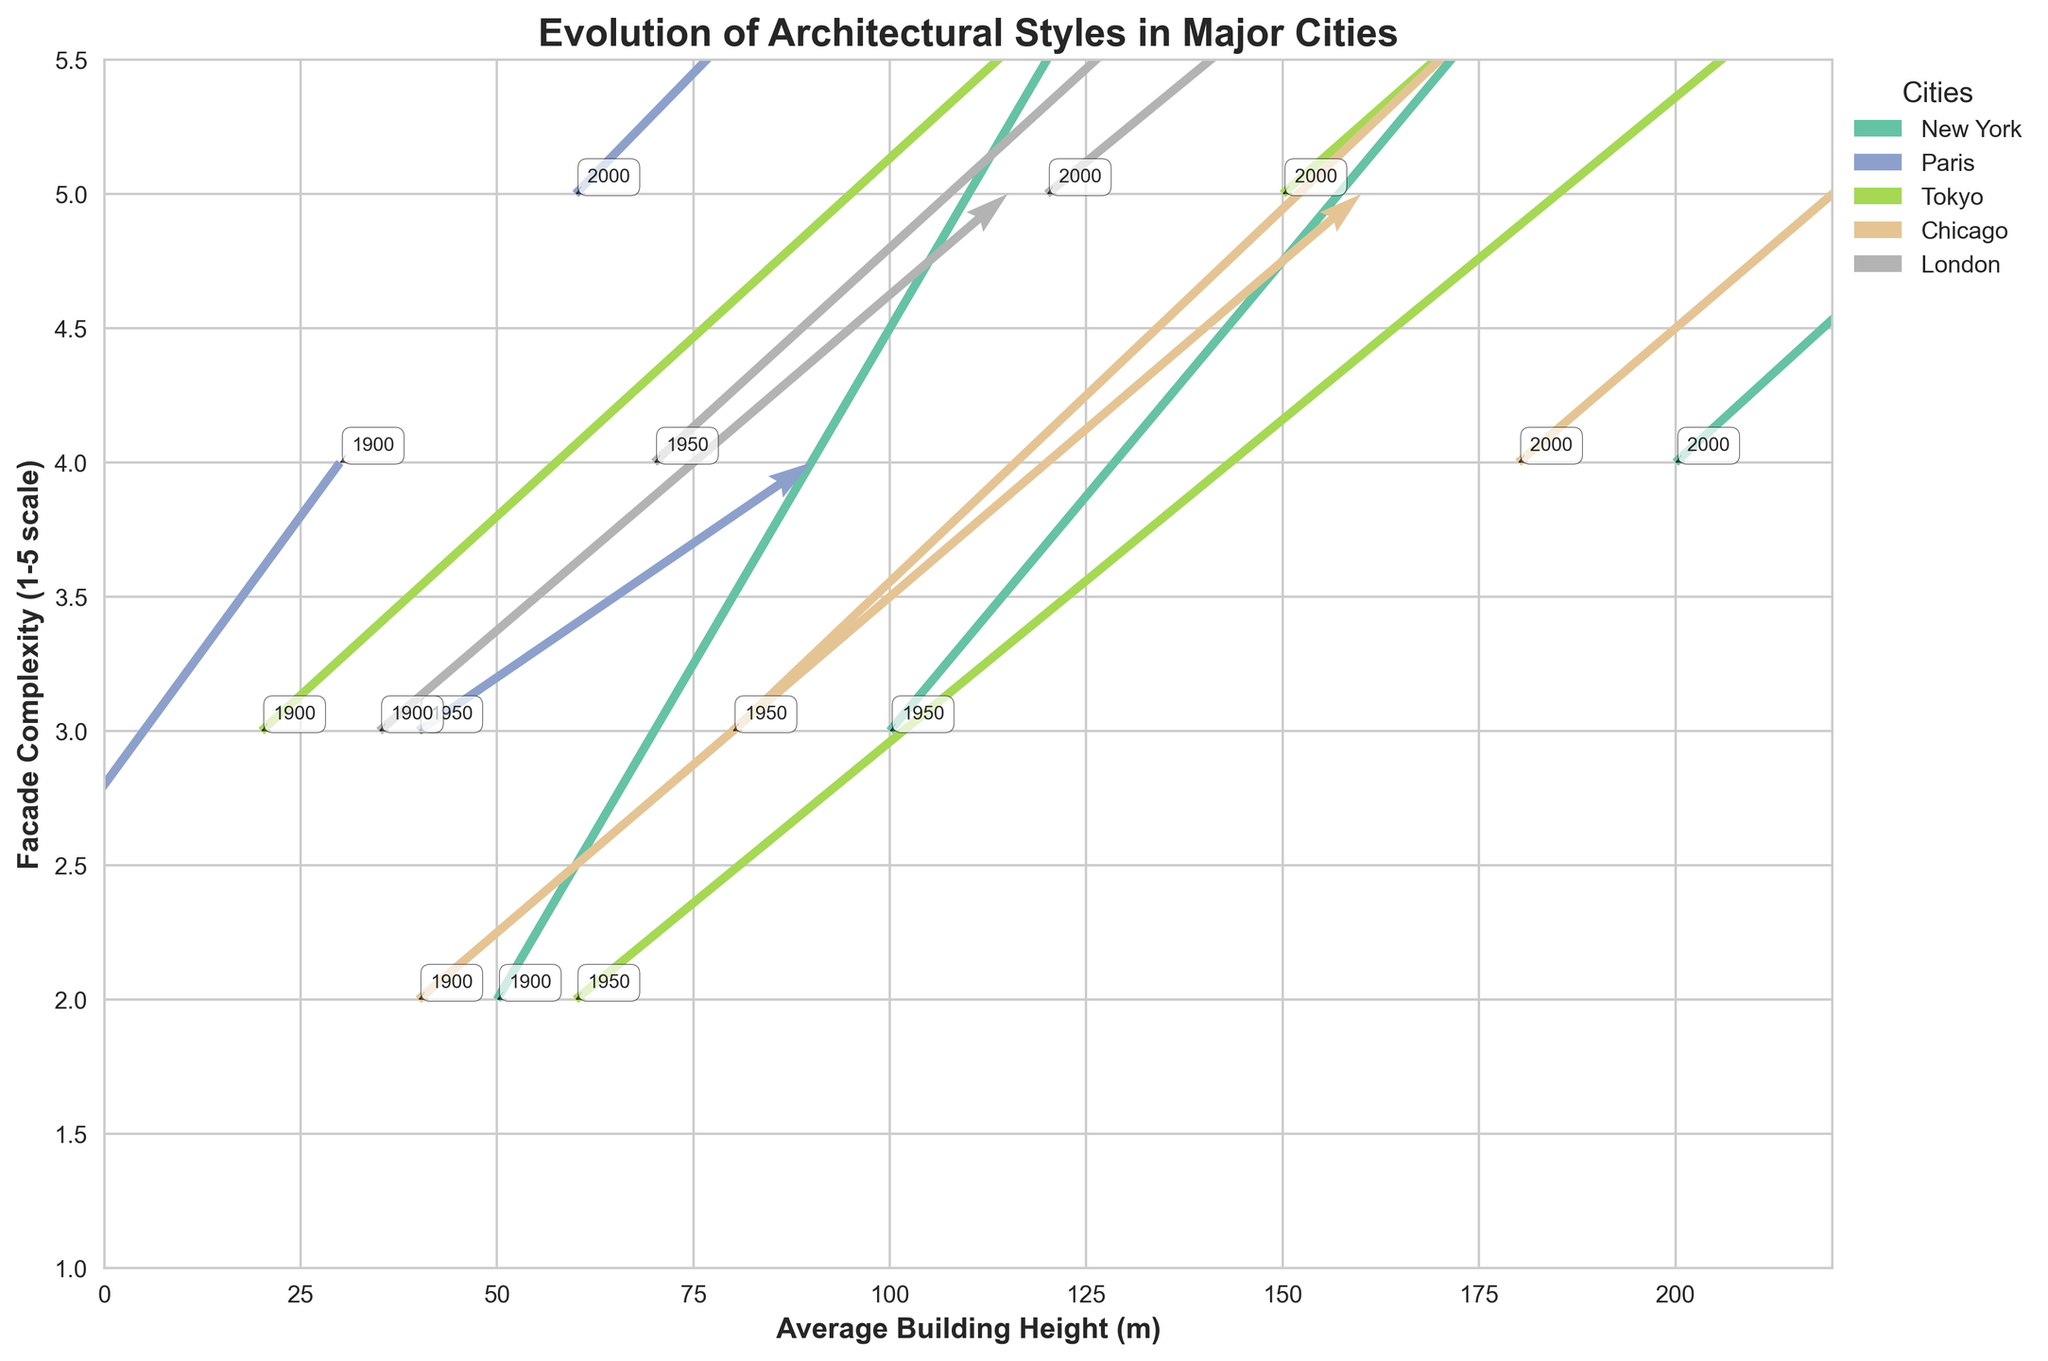What is the title of the plot? The title is usually written at the top of the plot and describes what the plot represents.
Answer: Evolution of Architectural Styles in Major Cities Which city had the largest average building height in the year 2000? By looking at the plotted points and their corresponding annotations for the year 2000, New York has the highest average building height among all the cities.
Answer: New York What is the x-axis label of the plot? The x-axis label is generally given beneath the horizontal axis and indicates what is being measured along this axis. Here it represents the height of buildings.
Answer: Average Building Height (m) Among New York, Paris, and Tokyo, which city experienced the greatest change in building height from 1900 to 2000? By comparing the arrows for each city from 1900 to 2000, Tokyo shows the largest change in building height, with increases occurring across different periods.
Answer: Tokyo What is the facade complexity of Paris in the year 1950? To find the facade complexity, locate the Paris data point for the year 1950 and refer to the y-axis value.
Answer: 3 What is the overall trend in facade complexity for Chicago from 1900 to 2000? By examining the quiver arrows for Chicago, observe that the facade complexity increases from 2 in 1900, to 3 in 1950, and to 4 in 2000.
Answer: Increasing Which city shows a decrease in facade complexity between 1900 and 1950? By observing all the quiver arrows from 1900 to 1950, Paris shows a decrease in facade complexity from 4 to 3.
Answer: Paris Compare the change in building heights of London and Chicago between the years 1900 and 2000. Which city had a larger increase? Calculate the difference in building heights for London (120-35 = 85 m) and for Chicago (180-40 = 140 m). Chicago had a larger increase in building height during this period.
Answer: Chicago What are the final facade complexity values for all cities in the year 2000? Look at the data points for each city in 2000 and read the y-values. New York: 4, Paris: 5, Tokyo: 5, Chicago: 4, London: 5
Answer: New York: 4, Paris: 5, Tokyo: 5, Chicago: 4, London: 5 Which city had the smallest average building height in the year 1900? By observing the 1900 data points for each city, Tokyo had the smallest average building height at 20 meters.
Answer: Tokyo 